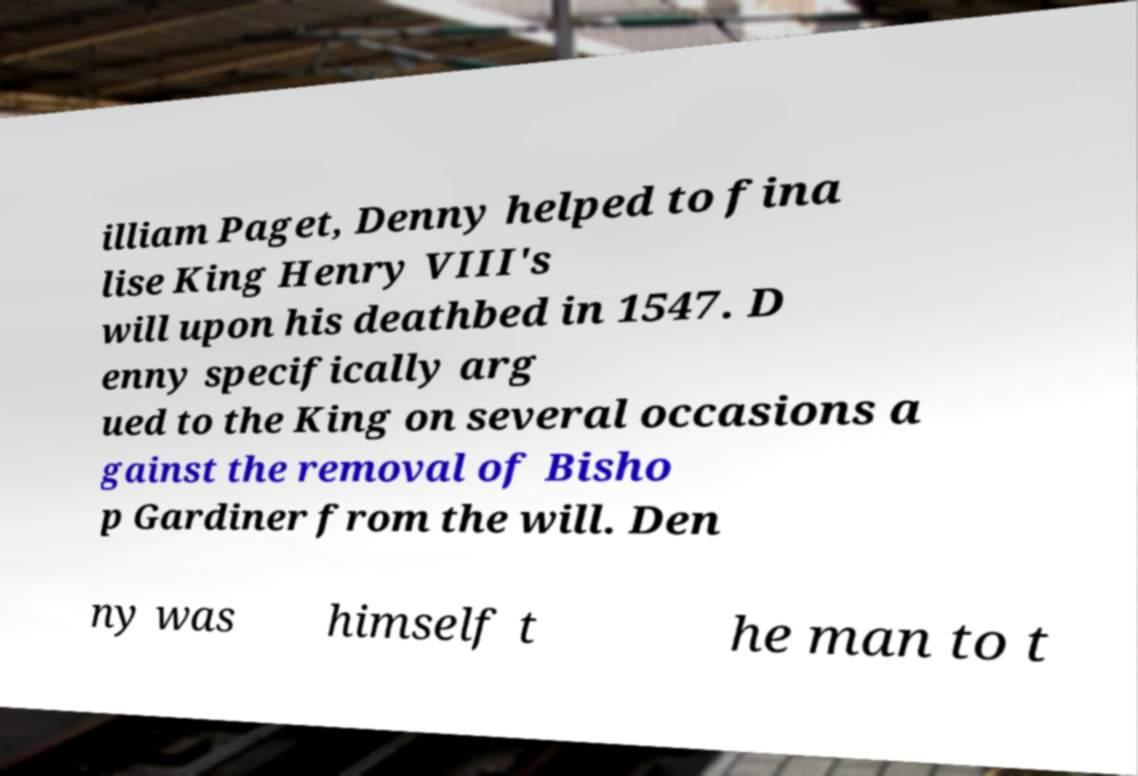Please identify and transcribe the text found in this image. illiam Paget, Denny helped to fina lise King Henry VIII's will upon his deathbed in 1547. D enny specifically arg ued to the King on several occasions a gainst the removal of Bisho p Gardiner from the will. Den ny was himself t he man to t 